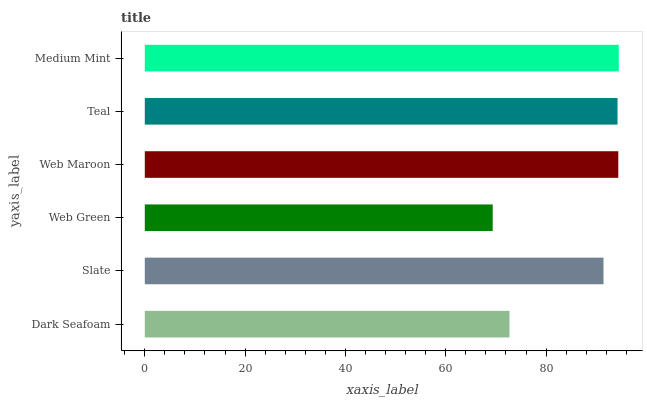Is Web Green the minimum?
Answer yes or no. Yes. Is Medium Mint the maximum?
Answer yes or no. Yes. Is Slate the minimum?
Answer yes or no. No. Is Slate the maximum?
Answer yes or no. No. Is Slate greater than Dark Seafoam?
Answer yes or no. Yes. Is Dark Seafoam less than Slate?
Answer yes or no. Yes. Is Dark Seafoam greater than Slate?
Answer yes or no. No. Is Slate less than Dark Seafoam?
Answer yes or no. No. Is Teal the high median?
Answer yes or no. Yes. Is Slate the low median?
Answer yes or no. Yes. Is Web Maroon the high median?
Answer yes or no. No. Is Web Maroon the low median?
Answer yes or no. No. 